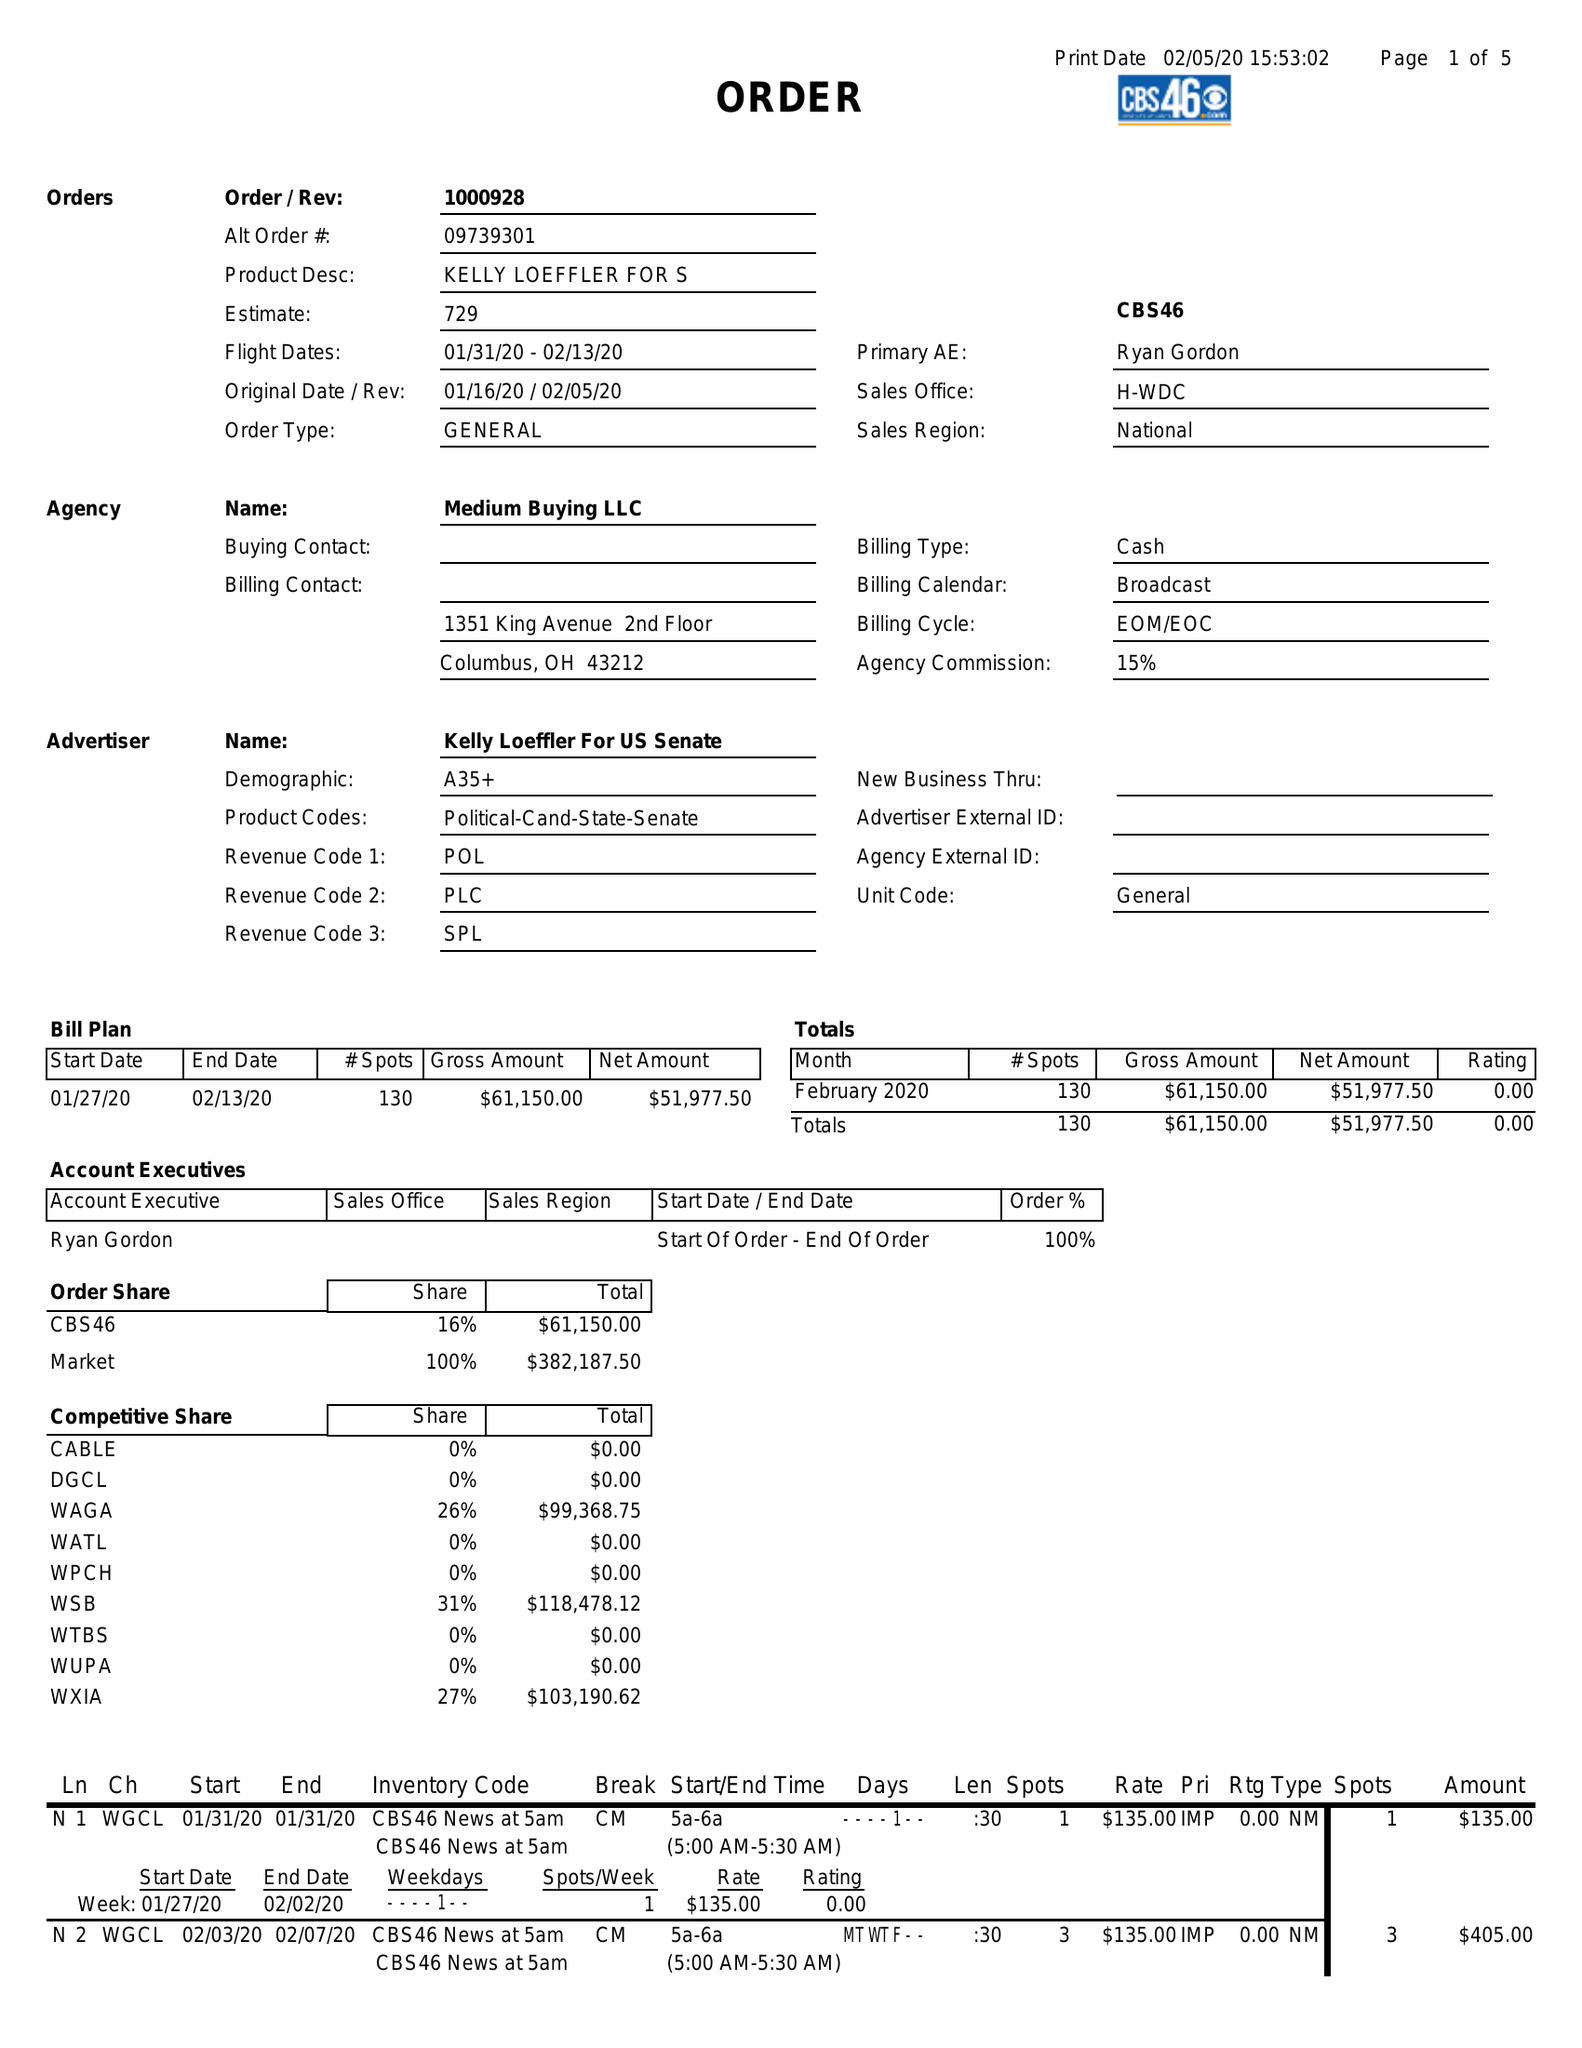What is the value for the flight_from?
Answer the question using a single word or phrase. 01/31/20 